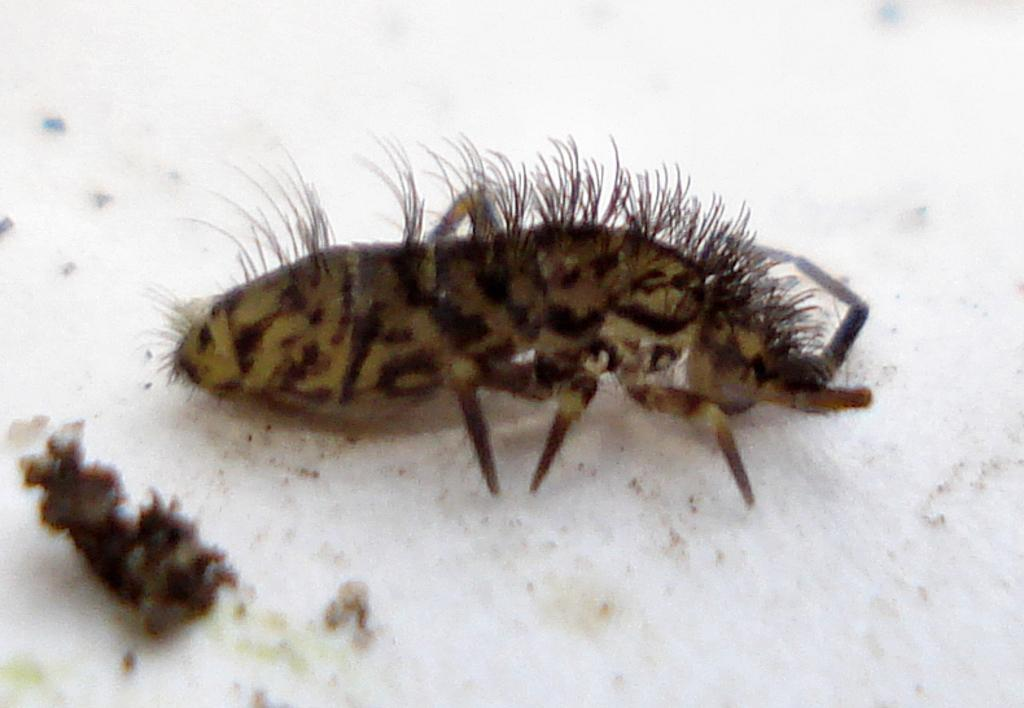What is the main subject of the picture? The main subject of the picture is an insect. What is the insect resting on in the image? The insect is on a white surface. Can you describe the insect's physical features? The insect has hair and legs. What else can be seen near the insect in the image? There are dust particles near the insect. What type of error can be seen in the prose written by the insect in the image? There is no prose or writing present in the image, and the insect is not capable of producing such content. 